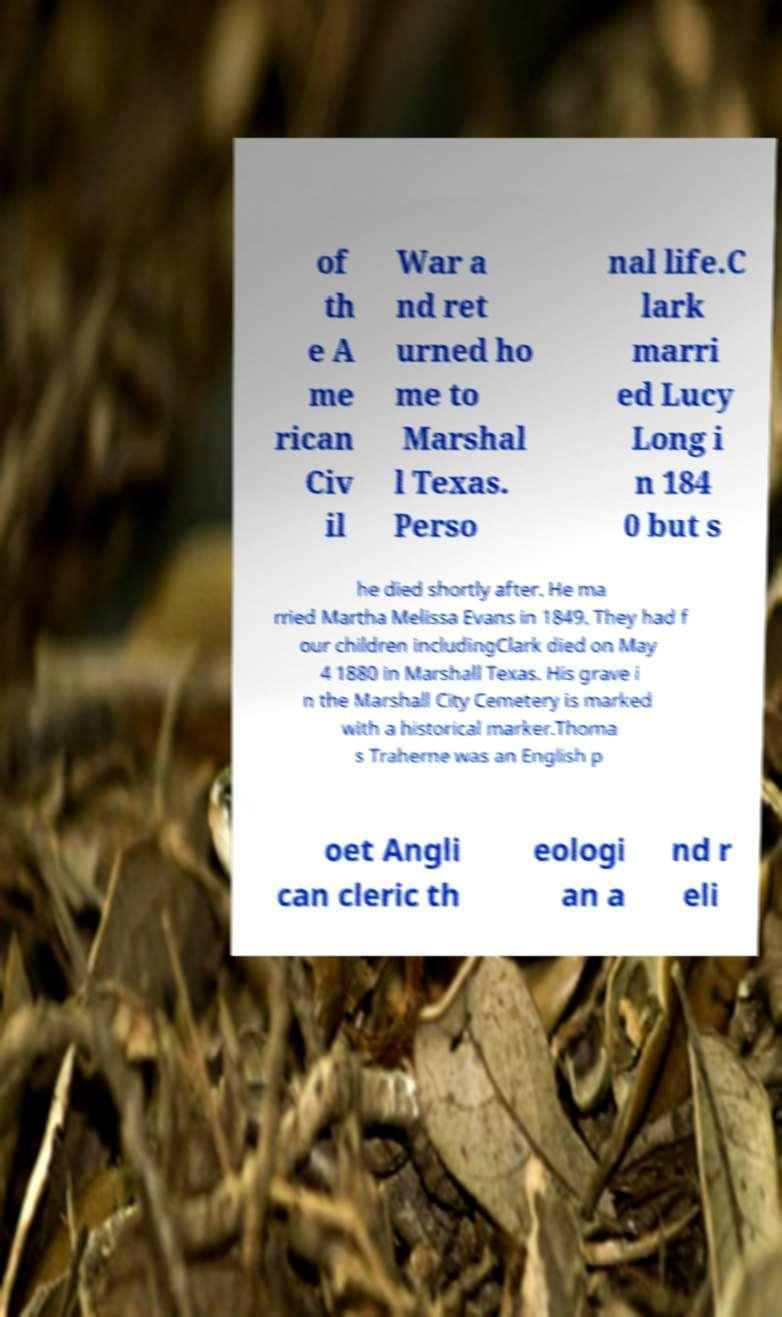Please read and relay the text visible in this image. What does it say? of th e A me rican Civ il War a nd ret urned ho me to Marshal l Texas. Perso nal life.C lark marri ed Lucy Long i n 184 0 but s he died shortly after. He ma rried Martha Melissa Evans in 1849. They had f our children includingClark died on May 4 1880 in Marshall Texas. His grave i n the Marshall City Cemetery is marked with a historical marker.Thoma s Traherne was an English p oet Angli can cleric th eologi an a nd r eli 